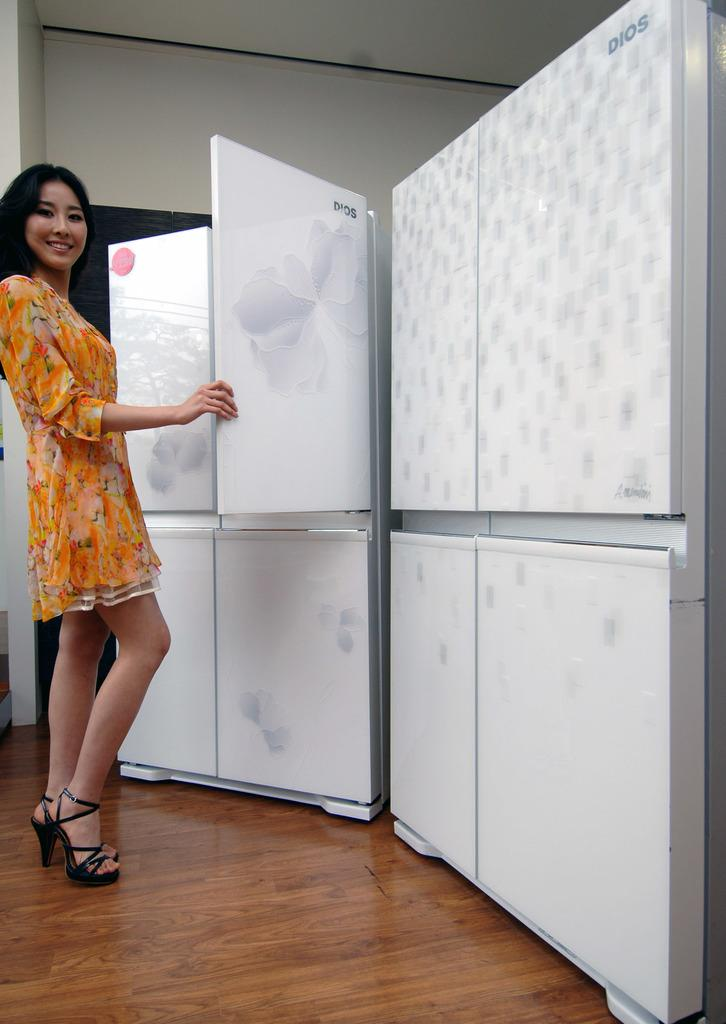<image>
Offer a succinct explanation of the picture presented. a woman in an orange dree opening a white cabinet by dios 